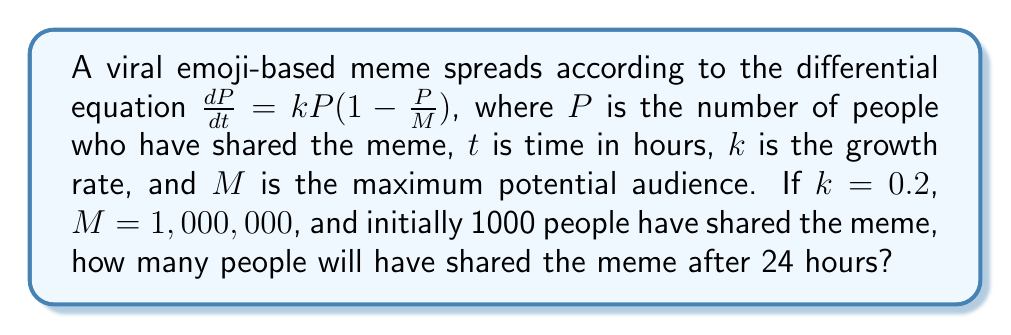Provide a solution to this math problem. 1. The given differential equation is the logistic growth model:
   $$\frac{dP}{dt} = kP(1-\frac{P}{M})$$

2. The solution to this equation is:
   $$P(t) = \frac{M}{1 + (\frac{M}{P_0} - 1)e^{-kt}}$$
   where $P_0$ is the initial number of people who shared the meme.

3. We're given:
   - $k = 0.2$
   - $M = 1,000,000$
   - $P_0 = 1000$
   - $t = 24$ hours

4. Substituting these values into the solution:
   $$P(24) = \frac{1,000,000}{1 + (\frac{1,000,000}{1000} - 1)e^{-0.2(24)}}$$

5. Simplify:
   $$P(24) = \frac{1,000,000}{1 + 999e^{-4.8}}$$

6. Calculate:
   $$P(24) = \frac{1,000,000}{1 + 999(0.00823)}$$
   $$P(24) = \frac{1,000,000}{9.22177}$$
   $$P(24) \approx 108,439$$

7. Round to the nearest whole number, as we can't have fractional people.
Answer: 108,439 people 